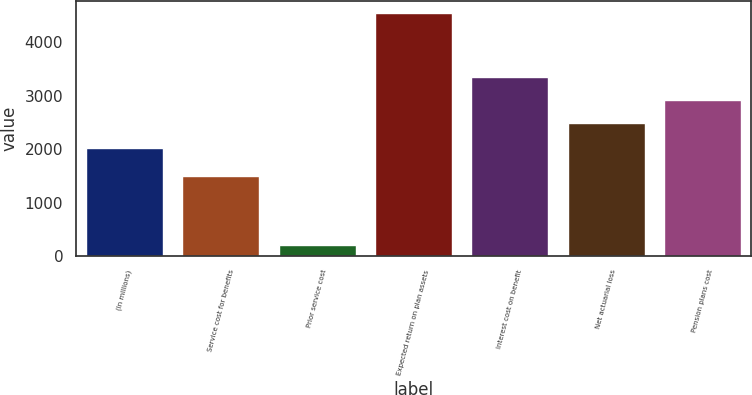Convert chart. <chart><loc_0><loc_0><loc_500><loc_500><bar_chart><fcel>(In millions)<fcel>Service cost for benefits<fcel>Prior service cost<fcel>Expected return on plan assets<fcel>Interest cost on benefit<fcel>Net actuarial loss<fcel>Pension plans cost<nl><fcel>2011<fcel>1498<fcel>207<fcel>4543<fcel>3353.2<fcel>2486<fcel>2919.6<nl></chart> 